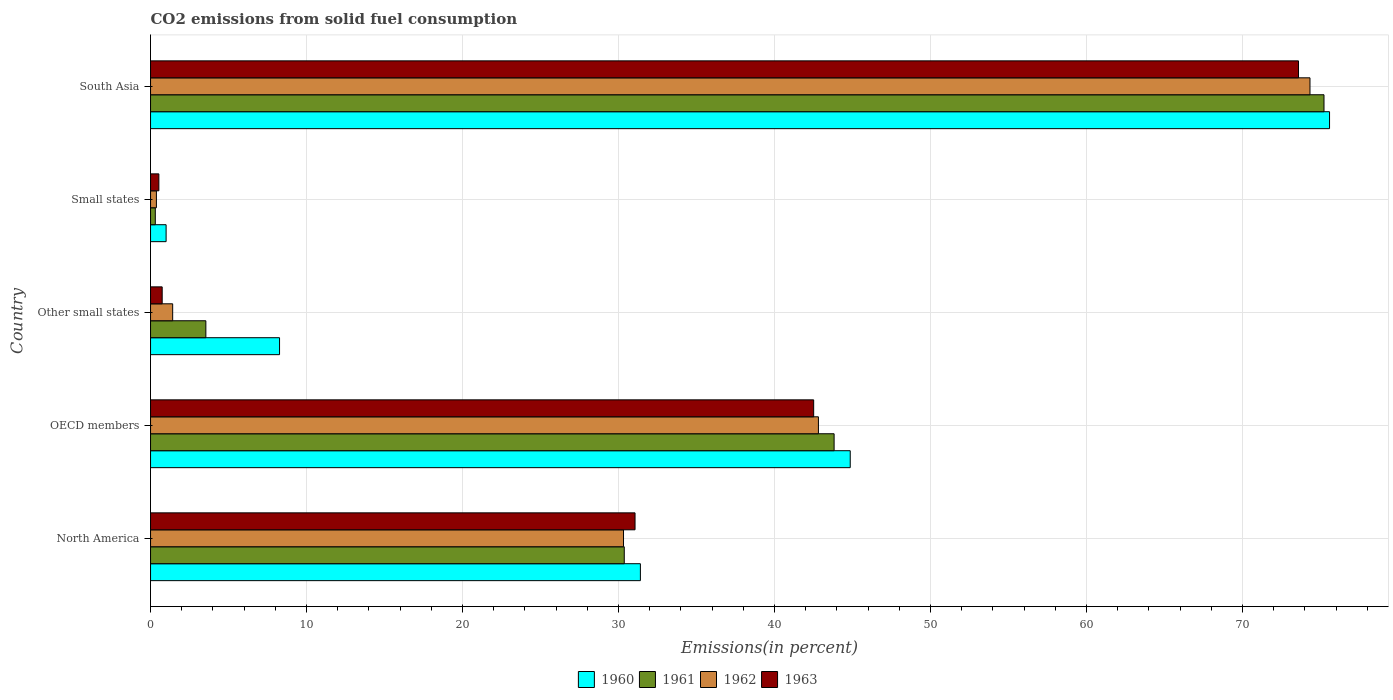How many groups of bars are there?
Your response must be concise. 5. Are the number of bars on each tick of the Y-axis equal?
Your answer should be compact. Yes. How many bars are there on the 4th tick from the bottom?
Give a very brief answer. 4. In how many cases, is the number of bars for a given country not equal to the number of legend labels?
Your response must be concise. 0. What is the total CO2 emitted in 1961 in Other small states?
Your answer should be very brief. 3.55. Across all countries, what is the maximum total CO2 emitted in 1961?
Give a very brief answer. 75.23. Across all countries, what is the minimum total CO2 emitted in 1960?
Keep it short and to the point. 1. In which country was the total CO2 emitted in 1963 maximum?
Offer a very short reply. South Asia. In which country was the total CO2 emitted in 1963 minimum?
Give a very brief answer. Small states. What is the total total CO2 emitted in 1962 in the graph?
Keep it short and to the point. 149.26. What is the difference between the total CO2 emitted in 1961 in North America and that in Other small states?
Your answer should be compact. 26.82. What is the difference between the total CO2 emitted in 1962 in OECD members and the total CO2 emitted in 1961 in Other small states?
Make the answer very short. 39.27. What is the average total CO2 emitted in 1962 per country?
Give a very brief answer. 29.85. What is the difference between the total CO2 emitted in 1960 and total CO2 emitted in 1962 in North America?
Make the answer very short. 1.08. What is the ratio of the total CO2 emitted in 1960 in Other small states to that in Small states?
Your answer should be compact. 8.28. Is the total CO2 emitted in 1963 in North America less than that in South Asia?
Keep it short and to the point. Yes. Is the difference between the total CO2 emitted in 1960 in North America and South Asia greater than the difference between the total CO2 emitted in 1962 in North America and South Asia?
Offer a very short reply. No. What is the difference between the highest and the second highest total CO2 emitted in 1960?
Offer a terse response. 30.73. What is the difference between the highest and the lowest total CO2 emitted in 1961?
Make the answer very short. 74.92. In how many countries, is the total CO2 emitted in 1963 greater than the average total CO2 emitted in 1963 taken over all countries?
Offer a terse response. 3. Is the sum of the total CO2 emitted in 1961 in OECD members and Small states greater than the maximum total CO2 emitted in 1962 across all countries?
Give a very brief answer. No. Is it the case that in every country, the sum of the total CO2 emitted in 1960 and total CO2 emitted in 1963 is greater than the sum of total CO2 emitted in 1962 and total CO2 emitted in 1961?
Provide a succinct answer. No. What does the 3rd bar from the top in South Asia represents?
Offer a terse response. 1961. How many bars are there?
Offer a terse response. 20. Are all the bars in the graph horizontal?
Your answer should be compact. Yes. What is the difference between two consecutive major ticks on the X-axis?
Provide a succinct answer. 10. Where does the legend appear in the graph?
Keep it short and to the point. Bottom center. How many legend labels are there?
Give a very brief answer. 4. What is the title of the graph?
Provide a succinct answer. CO2 emissions from solid fuel consumption. What is the label or title of the X-axis?
Keep it short and to the point. Emissions(in percent). What is the label or title of the Y-axis?
Make the answer very short. Country. What is the Emissions(in percent) in 1960 in North America?
Provide a succinct answer. 31.4. What is the Emissions(in percent) of 1961 in North America?
Provide a short and direct response. 30.37. What is the Emissions(in percent) of 1962 in North America?
Provide a short and direct response. 30.32. What is the Emissions(in percent) of 1963 in North America?
Provide a short and direct response. 31.06. What is the Emissions(in percent) in 1960 in OECD members?
Ensure brevity in your answer.  44.86. What is the Emissions(in percent) of 1961 in OECD members?
Make the answer very short. 43.82. What is the Emissions(in percent) of 1962 in OECD members?
Your answer should be very brief. 42.82. What is the Emissions(in percent) in 1963 in OECD members?
Your response must be concise. 42.51. What is the Emissions(in percent) in 1960 in Other small states?
Your response must be concise. 8.27. What is the Emissions(in percent) of 1961 in Other small states?
Make the answer very short. 3.55. What is the Emissions(in percent) in 1962 in Other small states?
Provide a short and direct response. 1.42. What is the Emissions(in percent) in 1963 in Other small states?
Make the answer very short. 0.75. What is the Emissions(in percent) in 1960 in Small states?
Keep it short and to the point. 1. What is the Emissions(in percent) in 1961 in Small states?
Provide a short and direct response. 0.31. What is the Emissions(in percent) of 1962 in Small states?
Provide a short and direct response. 0.38. What is the Emissions(in percent) in 1963 in Small states?
Keep it short and to the point. 0.53. What is the Emissions(in percent) of 1960 in South Asia?
Give a very brief answer. 75.58. What is the Emissions(in percent) in 1961 in South Asia?
Your response must be concise. 75.23. What is the Emissions(in percent) of 1962 in South Asia?
Keep it short and to the point. 74.33. What is the Emissions(in percent) in 1963 in South Asia?
Offer a terse response. 73.59. Across all countries, what is the maximum Emissions(in percent) of 1960?
Your answer should be very brief. 75.58. Across all countries, what is the maximum Emissions(in percent) in 1961?
Offer a terse response. 75.23. Across all countries, what is the maximum Emissions(in percent) in 1962?
Offer a very short reply. 74.33. Across all countries, what is the maximum Emissions(in percent) of 1963?
Provide a succinct answer. 73.59. Across all countries, what is the minimum Emissions(in percent) in 1960?
Give a very brief answer. 1. Across all countries, what is the minimum Emissions(in percent) in 1961?
Keep it short and to the point. 0.31. Across all countries, what is the minimum Emissions(in percent) of 1962?
Offer a terse response. 0.38. Across all countries, what is the minimum Emissions(in percent) of 1963?
Keep it short and to the point. 0.53. What is the total Emissions(in percent) of 1960 in the graph?
Your response must be concise. 161.11. What is the total Emissions(in percent) in 1961 in the graph?
Make the answer very short. 153.27. What is the total Emissions(in percent) in 1962 in the graph?
Give a very brief answer. 149.26. What is the total Emissions(in percent) in 1963 in the graph?
Offer a very short reply. 148.44. What is the difference between the Emissions(in percent) in 1960 in North America and that in OECD members?
Your response must be concise. -13.45. What is the difference between the Emissions(in percent) in 1961 in North America and that in OECD members?
Your answer should be compact. -13.45. What is the difference between the Emissions(in percent) of 1962 in North America and that in OECD members?
Ensure brevity in your answer.  -12.49. What is the difference between the Emissions(in percent) of 1963 in North America and that in OECD members?
Ensure brevity in your answer.  -11.45. What is the difference between the Emissions(in percent) in 1960 in North America and that in Other small states?
Ensure brevity in your answer.  23.13. What is the difference between the Emissions(in percent) in 1961 in North America and that in Other small states?
Provide a succinct answer. 26.82. What is the difference between the Emissions(in percent) in 1962 in North America and that in Other small states?
Your response must be concise. 28.9. What is the difference between the Emissions(in percent) in 1963 in North America and that in Other small states?
Your answer should be compact. 30.31. What is the difference between the Emissions(in percent) of 1960 in North America and that in Small states?
Give a very brief answer. 30.4. What is the difference between the Emissions(in percent) of 1961 in North America and that in Small states?
Give a very brief answer. 30.06. What is the difference between the Emissions(in percent) in 1962 in North America and that in Small states?
Your answer should be compact. 29.95. What is the difference between the Emissions(in percent) in 1963 in North America and that in Small states?
Keep it short and to the point. 30.53. What is the difference between the Emissions(in percent) in 1960 in North America and that in South Asia?
Ensure brevity in your answer.  -44.18. What is the difference between the Emissions(in percent) of 1961 in North America and that in South Asia?
Your answer should be compact. -44.86. What is the difference between the Emissions(in percent) of 1962 in North America and that in South Asia?
Provide a succinct answer. -44.01. What is the difference between the Emissions(in percent) in 1963 in North America and that in South Asia?
Give a very brief answer. -42.53. What is the difference between the Emissions(in percent) of 1960 in OECD members and that in Other small states?
Ensure brevity in your answer.  36.58. What is the difference between the Emissions(in percent) of 1961 in OECD members and that in Other small states?
Provide a succinct answer. 40.28. What is the difference between the Emissions(in percent) of 1962 in OECD members and that in Other small states?
Provide a short and direct response. 41.4. What is the difference between the Emissions(in percent) in 1963 in OECD members and that in Other small states?
Offer a terse response. 41.77. What is the difference between the Emissions(in percent) in 1960 in OECD members and that in Small states?
Your answer should be compact. 43.86. What is the difference between the Emissions(in percent) of 1961 in OECD members and that in Small states?
Ensure brevity in your answer.  43.52. What is the difference between the Emissions(in percent) in 1962 in OECD members and that in Small states?
Ensure brevity in your answer.  42.44. What is the difference between the Emissions(in percent) of 1963 in OECD members and that in Small states?
Offer a very short reply. 41.98. What is the difference between the Emissions(in percent) of 1960 in OECD members and that in South Asia?
Provide a short and direct response. -30.73. What is the difference between the Emissions(in percent) of 1961 in OECD members and that in South Asia?
Offer a very short reply. -31.41. What is the difference between the Emissions(in percent) in 1962 in OECD members and that in South Asia?
Offer a terse response. -31.51. What is the difference between the Emissions(in percent) in 1963 in OECD members and that in South Asia?
Your answer should be compact. -31.08. What is the difference between the Emissions(in percent) in 1960 in Other small states and that in Small states?
Give a very brief answer. 7.27. What is the difference between the Emissions(in percent) in 1961 in Other small states and that in Small states?
Keep it short and to the point. 3.24. What is the difference between the Emissions(in percent) in 1962 in Other small states and that in Small states?
Your response must be concise. 1.04. What is the difference between the Emissions(in percent) of 1963 in Other small states and that in Small states?
Ensure brevity in your answer.  0.21. What is the difference between the Emissions(in percent) of 1960 in Other small states and that in South Asia?
Offer a very short reply. -67.31. What is the difference between the Emissions(in percent) of 1961 in Other small states and that in South Asia?
Make the answer very short. -71.68. What is the difference between the Emissions(in percent) of 1962 in Other small states and that in South Asia?
Your response must be concise. -72.91. What is the difference between the Emissions(in percent) of 1963 in Other small states and that in South Asia?
Provide a succinct answer. -72.85. What is the difference between the Emissions(in percent) in 1960 in Small states and that in South Asia?
Give a very brief answer. -74.58. What is the difference between the Emissions(in percent) of 1961 in Small states and that in South Asia?
Keep it short and to the point. -74.92. What is the difference between the Emissions(in percent) of 1962 in Small states and that in South Asia?
Your response must be concise. -73.95. What is the difference between the Emissions(in percent) of 1963 in Small states and that in South Asia?
Provide a succinct answer. -73.06. What is the difference between the Emissions(in percent) in 1960 in North America and the Emissions(in percent) in 1961 in OECD members?
Your answer should be compact. -12.42. What is the difference between the Emissions(in percent) of 1960 in North America and the Emissions(in percent) of 1962 in OECD members?
Ensure brevity in your answer.  -11.41. What is the difference between the Emissions(in percent) in 1960 in North America and the Emissions(in percent) in 1963 in OECD members?
Your answer should be compact. -11.11. What is the difference between the Emissions(in percent) of 1961 in North America and the Emissions(in percent) of 1962 in OECD members?
Make the answer very short. -12.45. What is the difference between the Emissions(in percent) of 1961 in North America and the Emissions(in percent) of 1963 in OECD members?
Provide a short and direct response. -12.14. What is the difference between the Emissions(in percent) in 1962 in North America and the Emissions(in percent) in 1963 in OECD members?
Provide a succinct answer. -12.19. What is the difference between the Emissions(in percent) in 1960 in North America and the Emissions(in percent) in 1961 in Other small states?
Provide a short and direct response. 27.86. What is the difference between the Emissions(in percent) in 1960 in North America and the Emissions(in percent) in 1962 in Other small states?
Your answer should be compact. 29.98. What is the difference between the Emissions(in percent) of 1960 in North America and the Emissions(in percent) of 1963 in Other small states?
Provide a succinct answer. 30.66. What is the difference between the Emissions(in percent) in 1961 in North America and the Emissions(in percent) in 1962 in Other small states?
Make the answer very short. 28.95. What is the difference between the Emissions(in percent) of 1961 in North America and the Emissions(in percent) of 1963 in Other small states?
Your response must be concise. 29.62. What is the difference between the Emissions(in percent) in 1962 in North America and the Emissions(in percent) in 1963 in Other small states?
Provide a short and direct response. 29.58. What is the difference between the Emissions(in percent) of 1960 in North America and the Emissions(in percent) of 1961 in Small states?
Ensure brevity in your answer.  31.1. What is the difference between the Emissions(in percent) of 1960 in North America and the Emissions(in percent) of 1962 in Small states?
Provide a succinct answer. 31.03. What is the difference between the Emissions(in percent) of 1960 in North America and the Emissions(in percent) of 1963 in Small states?
Your response must be concise. 30.87. What is the difference between the Emissions(in percent) in 1961 in North America and the Emissions(in percent) in 1962 in Small states?
Make the answer very short. 29.99. What is the difference between the Emissions(in percent) in 1961 in North America and the Emissions(in percent) in 1963 in Small states?
Make the answer very short. 29.84. What is the difference between the Emissions(in percent) of 1962 in North America and the Emissions(in percent) of 1963 in Small states?
Offer a terse response. 29.79. What is the difference between the Emissions(in percent) of 1960 in North America and the Emissions(in percent) of 1961 in South Asia?
Offer a very short reply. -43.82. What is the difference between the Emissions(in percent) in 1960 in North America and the Emissions(in percent) in 1962 in South Asia?
Offer a terse response. -42.93. What is the difference between the Emissions(in percent) in 1960 in North America and the Emissions(in percent) in 1963 in South Asia?
Give a very brief answer. -42.19. What is the difference between the Emissions(in percent) in 1961 in North America and the Emissions(in percent) in 1962 in South Asia?
Your answer should be compact. -43.96. What is the difference between the Emissions(in percent) of 1961 in North America and the Emissions(in percent) of 1963 in South Asia?
Keep it short and to the point. -43.22. What is the difference between the Emissions(in percent) in 1962 in North America and the Emissions(in percent) in 1963 in South Asia?
Offer a very short reply. -43.27. What is the difference between the Emissions(in percent) of 1960 in OECD members and the Emissions(in percent) of 1961 in Other small states?
Make the answer very short. 41.31. What is the difference between the Emissions(in percent) of 1960 in OECD members and the Emissions(in percent) of 1962 in Other small states?
Offer a very short reply. 43.44. What is the difference between the Emissions(in percent) of 1960 in OECD members and the Emissions(in percent) of 1963 in Other small states?
Keep it short and to the point. 44.11. What is the difference between the Emissions(in percent) of 1961 in OECD members and the Emissions(in percent) of 1962 in Other small states?
Offer a very short reply. 42.4. What is the difference between the Emissions(in percent) in 1961 in OECD members and the Emissions(in percent) in 1963 in Other small states?
Keep it short and to the point. 43.08. What is the difference between the Emissions(in percent) in 1962 in OECD members and the Emissions(in percent) in 1963 in Other small states?
Offer a terse response. 42.07. What is the difference between the Emissions(in percent) of 1960 in OECD members and the Emissions(in percent) of 1961 in Small states?
Your answer should be compact. 44.55. What is the difference between the Emissions(in percent) of 1960 in OECD members and the Emissions(in percent) of 1962 in Small states?
Make the answer very short. 44.48. What is the difference between the Emissions(in percent) of 1960 in OECD members and the Emissions(in percent) of 1963 in Small states?
Keep it short and to the point. 44.32. What is the difference between the Emissions(in percent) of 1961 in OECD members and the Emissions(in percent) of 1962 in Small states?
Offer a very short reply. 43.45. What is the difference between the Emissions(in percent) of 1961 in OECD members and the Emissions(in percent) of 1963 in Small states?
Your answer should be compact. 43.29. What is the difference between the Emissions(in percent) of 1962 in OECD members and the Emissions(in percent) of 1963 in Small states?
Give a very brief answer. 42.28. What is the difference between the Emissions(in percent) in 1960 in OECD members and the Emissions(in percent) in 1961 in South Asia?
Provide a succinct answer. -30.37. What is the difference between the Emissions(in percent) of 1960 in OECD members and the Emissions(in percent) of 1962 in South Asia?
Your answer should be very brief. -29.47. What is the difference between the Emissions(in percent) of 1960 in OECD members and the Emissions(in percent) of 1963 in South Asia?
Offer a very short reply. -28.74. What is the difference between the Emissions(in percent) in 1961 in OECD members and the Emissions(in percent) in 1962 in South Asia?
Make the answer very short. -30.51. What is the difference between the Emissions(in percent) of 1961 in OECD members and the Emissions(in percent) of 1963 in South Asia?
Offer a very short reply. -29.77. What is the difference between the Emissions(in percent) of 1962 in OECD members and the Emissions(in percent) of 1963 in South Asia?
Your answer should be compact. -30.78. What is the difference between the Emissions(in percent) in 1960 in Other small states and the Emissions(in percent) in 1961 in Small states?
Your answer should be compact. 7.96. What is the difference between the Emissions(in percent) of 1960 in Other small states and the Emissions(in percent) of 1962 in Small states?
Offer a very short reply. 7.89. What is the difference between the Emissions(in percent) in 1960 in Other small states and the Emissions(in percent) in 1963 in Small states?
Ensure brevity in your answer.  7.74. What is the difference between the Emissions(in percent) of 1961 in Other small states and the Emissions(in percent) of 1962 in Small states?
Offer a terse response. 3.17. What is the difference between the Emissions(in percent) in 1961 in Other small states and the Emissions(in percent) in 1963 in Small states?
Ensure brevity in your answer.  3.01. What is the difference between the Emissions(in percent) of 1962 in Other small states and the Emissions(in percent) of 1963 in Small states?
Offer a very short reply. 0.88. What is the difference between the Emissions(in percent) in 1960 in Other small states and the Emissions(in percent) in 1961 in South Asia?
Provide a short and direct response. -66.96. What is the difference between the Emissions(in percent) of 1960 in Other small states and the Emissions(in percent) of 1962 in South Asia?
Offer a very short reply. -66.06. What is the difference between the Emissions(in percent) in 1960 in Other small states and the Emissions(in percent) in 1963 in South Asia?
Give a very brief answer. -65.32. What is the difference between the Emissions(in percent) in 1961 in Other small states and the Emissions(in percent) in 1962 in South Asia?
Provide a short and direct response. -70.78. What is the difference between the Emissions(in percent) of 1961 in Other small states and the Emissions(in percent) of 1963 in South Asia?
Ensure brevity in your answer.  -70.05. What is the difference between the Emissions(in percent) of 1962 in Other small states and the Emissions(in percent) of 1963 in South Asia?
Provide a succinct answer. -72.17. What is the difference between the Emissions(in percent) in 1960 in Small states and the Emissions(in percent) in 1961 in South Asia?
Offer a very short reply. -74.23. What is the difference between the Emissions(in percent) of 1960 in Small states and the Emissions(in percent) of 1962 in South Asia?
Your answer should be very brief. -73.33. What is the difference between the Emissions(in percent) of 1960 in Small states and the Emissions(in percent) of 1963 in South Asia?
Offer a terse response. -72.59. What is the difference between the Emissions(in percent) of 1961 in Small states and the Emissions(in percent) of 1962 in South Asia?
Give a very brief answer. -74.02. What is the difference between the Emissions(in percent) in 1961 in Small states and the Emissions(in percent) in 1963 in South Asia?
Offer a terse response. -73.29. What is the difference between the Emissions(in percent) in 1962 in Small states and the Emissions(in percent) in 1963 in South Asia?
Offer a very short reply. -73.22. What is the average Emissions(in percent) in 1960 per country?
Provide a succinct answer. 32.22. What is the average Emissions(in percent) of 1961 per country?
Give a very brief answer. 30.65. What is the average Emissions(in percent) of 1962 per country?
Offer a very short reply. 29.85. What is the average Emissions(in percent) of 1963 per country?
Provide a succinct answer. 29.69. What is the difference between the Emissions(in percent) in 1960 and Emissions(in percent) in 1961 in North America?
Offer a very short reply. 1.03. What is the difference between the Emissions(in percent) in 1960 and Emissions(in percent) in 1962 in North America?
Your answer should be compact. 1.08. What is the difference between the Emissions(in percent) of 1960 and Emissions(in percent) of 1963 in North America?
Keep it short and to the point. 0.34. What is the difference between the Emissions(in percent) in 1961 and Emissions(in percent) in 1962 in North America?
Your response must be concise. 0.05. What is the difference between the Emissions(in percent) in 1961 and Emissions(in percent) in 1963 in North America?
Your answer should be compact. -0.69. What is the difference between the Emissions(in percent) of 1962 and Emissions(in percent) of 1963 in North America?
Provide a short and direct response. -0.74. What is the difference between the Emissions(in percent) of 1960 and Emissions(in percent) of 1961 in OECD members?
Ensure brevity in your answer.  1.03. What is the difference between the Emissions(in percent) of 1960 and Emissions(in percent) of 1962 in OECD members?
Offer a terse response. 2.04. What is the difference between the Emissions(in percent) of 1960 and Emissions(in percent) of 1963 in OECD members?
Offer a terse response. 2.34. What is the difference between the Emissions(in percent) in 1961 and Emissions(in percent) in 1963 in OECD members?
Keep it short and to the point. 1.31. What is the difference between the Emissions(in percent) of 1962 and Emissions(in percent) of 1963 in OECD members?
Your response must be concise. 0.3. What is the difference between the Emissions(in percent) of 1960 and Emissions(in percent) of 1961 in Other small states?
Give a very brief answer. 4.72. What is the difference between the Emissions(in percent) of 1960 and Emissions(in percent) of 1962 in Other small states?
Provide a short and direct response. 6.85. What is the difference between the Emissions(in percent) in 1960 and Emissions(in percent) in 1963 in Other small states?
Your response must be concise. 7.52. What is the difference between the Emissions(in percent) of 1961 and Emissions(in percent) of 1962 in Other small states?
Provide a short and direct response. 2.13. What is the difference between the Emissions(in percent) in 1961 and Emissions(in percent) in 1963 in Other small states?
Ensure brevity in your answer.  2.8. What is the difference between the Emissions(in percent) in 1962 and Emissions(in percent) in 1963 in Other small states?
Make the answer very short. 0.67. What is the difference between the Emissions(in percent) in 1960 and Emissions(in percent) in 1961 in Small states?
Ensure brevity in your answer.  0.69. What is the difference between the Emissions(in percent) in 1960 and Emissions(in percent) in 1962 in Small states?
Keep it short and to the point. 0.62. What is the difference between the Emissions(in percent) in 1960 and Emissions(in percent) in 1963 in Small states?
Offer a very short reply. 0.46. What is the difference between the Emissions(in percent) of 1961 and Emissions(in percent) of 1962 in Small states?
Your response must be concise. -0.07. What is the difference between the Emissions(in percent) in 1961 and Emissions(in percent) in 1963 in Small states?
Offer a terse response. -0.23. What is the difference between the Emissions(in percent) in 1962 and Emissions(in percent) in 1963 in Small states?
Offer a terse response. -0.16. What is the difference between the Emissions(in percent) of 1960 and Emissions(in percent) of 1961 in South Asia?
Give a very brief answer. 0.36. What is the difference between the Emissions(in percent) in 1960 and Emissions(in percent) in 1962 in South Asia?
Keep it short and to the point. 1.25. What is the difference between the Emissions(in percent) in 1960 and Emissions(in percent) in 1963 in South Asia?
Keep it short and to the point. 1.99. What is the difference between the Emissions(in percent) in 1961 and Emissions(in percent) in 1962 in South Asia?
Make the answer very short. 0.9. What is the difference between the Emissions(in percent) in 1961 and Emissions(in percent) in 1963 in South Asia?
Make the answer very short. 1.63. What is the difference between the Emissions(in percent) of 1962 and Emissions(in percent) of 1963 in South Asia?
Your response must be concise. 0.74. What is the ratio of the Emissions(in percent) of 1960 in North America to that in OECD members?
Offer a terse response. 0.7. What is the ratio of the Emissions(in percent) of 1961 in North America to that in OECD members?
Keep it short and to the point. 0.69. What is the ratio of the Emissions(in percent) in 1962 in North America to that in OECD members?
Make the answer very short. 0.71. What is the ratio of the Emissions(in percent) in 1963 in North America to that in OECD members?
Your answer should be very brief. 0.73. What is the ratio of the Emissions(in percent) of 1960 in North America to that in Other small states?
Give a very brief answer. 3.8. What is the ratio of the Emissions(in percent) in 1961 in North America to that in Other small states?
Make the answer very short. 8.56. What is the ratio of the Emissions(in percent) of 1962 in North America to that in Other small states?
Offer a very short reply. 21.38. What is the ratio of the Emissions(in percent) of 1963 in North America to that in Other small states?
Ensure brevity in your answer.  41.62. What is the ratio of the Emissions(in percent) of 1960 in North America to that in Small states?
Make the answer very short. 31.46. What is the ratio of the Emissions(in percent) of 1961 in North America to that in Small states?
Give a very brief answer. 99.31. What is the ratio of the Emissions(in percent) in 1962 in North America to that in Small states?
Your answer should be compact. 80.56. What is the ratio of the Emissions(in percent) in 1963 in North America to that in Small states?
Provide a short and direct response. 58.21. What is the ratio of the Emissions(in percent) in 1960 in North America to that in South Asia?
Your response must be concise. 0.42. What is the ratio of the Emissions(in percent) in 1961 in North America to that in South Asia?
Offer a very short reply. 0.4. What is the ratio of the Emissions(in percent) in 1962 in North America to that in South Asia?
Ensure brevity in your answer.  0.41. What is the ratio of the Emissions(in percent) in 1963 in North America to that in South Asia?
Your response must be concise. 0.42. What is the ratio of the Emissions(in percent) in 1960 in OECD members to that in Other small states?
Make the answer very short. 5.42. What is the ratio of the Emissions(in percent) of 1961 in OECD members to that in Other small states?
Your answer should be very brief. 12.36. What is the ratio of the Emissions(in percent) of 1962 in OECD members to that in Other small states?
Offer a terse response. 30.19. What is the ratio of the Emissions(in percent) in 1963 in OECD members to that in Other small states?
Your answer should be very brief. 56.97. What is the ratio of the Emissions(in percent) of 1960 in OECD members to that in Small states?
Keep it short and to the point. 44.93. What is the ratio of the Emissions(in percent) of 1961 in OECD members to that in Small states?
Your response must be concise. 143.3. What is the ratio of the Emissions(in percent) in 1962 in OECD members to that in Small states?
Offer a terse response. 113.76. What is the ratio of the Emissions(in percent) in 1963 in OECD members to that in Small states?
Your answer should be compact. 79.67. What is the ratio of the Emissions(in percent) in 1960 in OECD members to that in South Asia?
Your answer should be compact. 0.59. What is the ratio of the Emissions(in percent) in 1961 in OECD members to that in South Asia?
Provide a succinct answer. 0.58. What is the ratio of the Emissions(in percent) of 1962 in OECD members to that in South Asia?
Your response must be concise. 0.58. What is the ratio of the Emissions(in percent) in 1963 in OECD members to that in South Asia?
Keep it short and to the point. 0.58. What is the ratio of the Emissions(in percent) in 1960 in Other small states to that in Small states?
Your response must be concise. 8.28. What is the ratio of the Emissions(in percent) in 1961 in Other small states to that in Small states?
Keep it short and to the point. 11.6. What is the ratio of the Emissions(in percent) in 1962 in Other small states to that in Small states?
Your answer should be compact. 3.77. What is the ratio of the Emissions(in percent) of 1963 in Other small states to that in Small states?
Keep it short and to the point. 1.4. What is the ratio of the Emissions(in percent) in 1960 in Other small states to that in South Asia?
Make the answer very short. 0.11. What is the ratio of the Emissions(in percent) of 1961 in Other small states to that in South Asia?
Provide a short and direct response. 0.05. What is the ratio of the Emissions(in percent) of 1962 in Other small states to that in South Asia?
Your answer should be very brief. 0.02. What is the ratio of the Emissions(in percent) in 1963 in Other small states to that in South Asia?
Keep it short and to the point. 0.01. What is the ratio of the Emissions(in percent) in 1960 in Small states to that in South Asia?
Give a very brief answer. 0.01. What is the ratio of the Emissions(in percent) in 1961 in Small states to that in South Asia?
Offer a terse response. 0. What is the ratio of the Emissions(in percent) of 1962 in Small states to that in South Asia?
Offer a terse response. 0.01. What is the ratio of the Emissions(in percent) of 1963 in Small states to that in South Asia?
Provide a short and direct response. 0.01. What is the difference between the highest and the second highest Emissions(in percent) of 1960?
Offer a very short reply. 30.73. What is the difference between the highest and the second highest Emissions(in percent) in 1961?
Your response must be concise. 31.41. What is the difference between the highest and the second highest Emissions(in percent) of 1962?
Provide a short and direct response. 31.51. What is the difference between the highest and the second highest Emissions(in percent) of 1963?
Make the answer very short. 31.08. What is the difference between the highest and the lowest Emissions(in percent) in 1960?
Your answer should be compact. 74.58. What is the difference between the highest and the lowest Emissions(in percent) of 1961?
Make the answer very short. 74.92. What is the difference between the highest and the lowest Emissions(in percent) of 1962?
Offer a terse response. 73.95. What is the difference between the highest and the lowest Emissions(in percent) in 1963?
Provide a short and direct response. 73.06. 